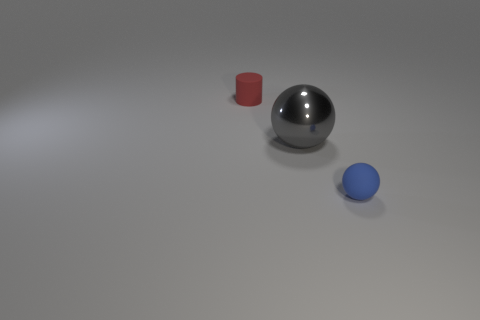Is the size of the red cylinder the same as the gray object?
Your answer should be very brief. No. The rubber ball has what color?
Keep it short and to the point. Blue. What number of things are blue rubber things or tiny matte cylinders?
Your response must be concise. 2. Are there any tiny red objects that have the same shape as the large gray thing?
Make the answer very short. No. Is the color of the rubber thing in front of the tiny red thing the same as the tiny rubber cylinder?
Your answer should be very brief. No. What is the shape of the tiny object that is on the right side of the rubber object behind the matte ball?
Offer a terse response. Sphere. Is there a brown matte cylinder that has the same size as the gray sphere?
Give a very brief answer. No. Is the number of small red matte spheres less than the number of rubber things?
Provide a short and direct response. Yes. What shape is the shiny object that is on the left side of the small thing in front of the small rubber thing to the left of the large gray ball?
Provide a short and direct response. Sphere. What number of things are objects that are on the right side of the small red thing or rubber things that are on the left side of the blue ball?
Offer a terse response. 3. 